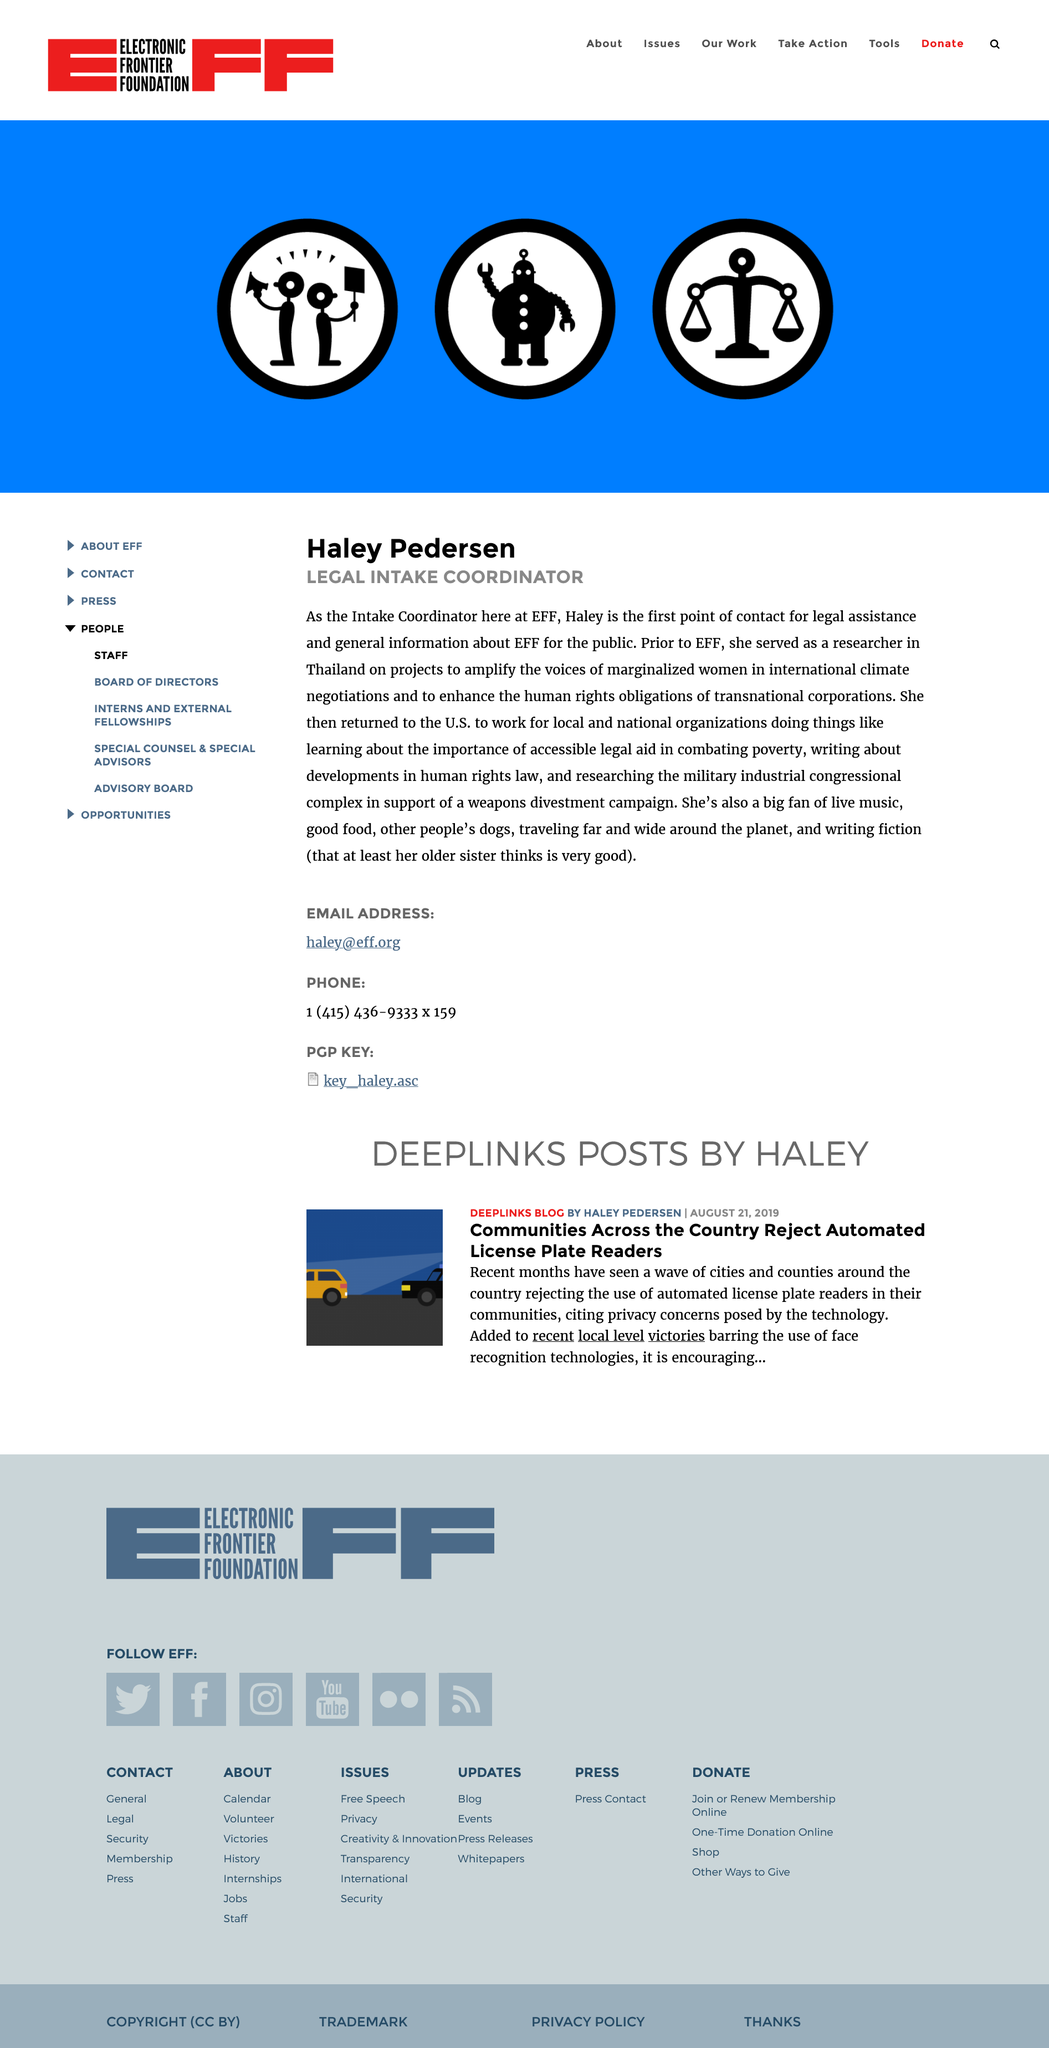Draw attention to some important aspects in this diagram. Haley Pedersen is the Legal Intake Coordinator. Haley Pedersen, prior to her affiliation with the Electronic Frontier Foundation (EFF), served as a researcher in Thailand, where she conducted research on issues related to intellectual property and digital rights. Haley is the first point of contact for legal assistance. 